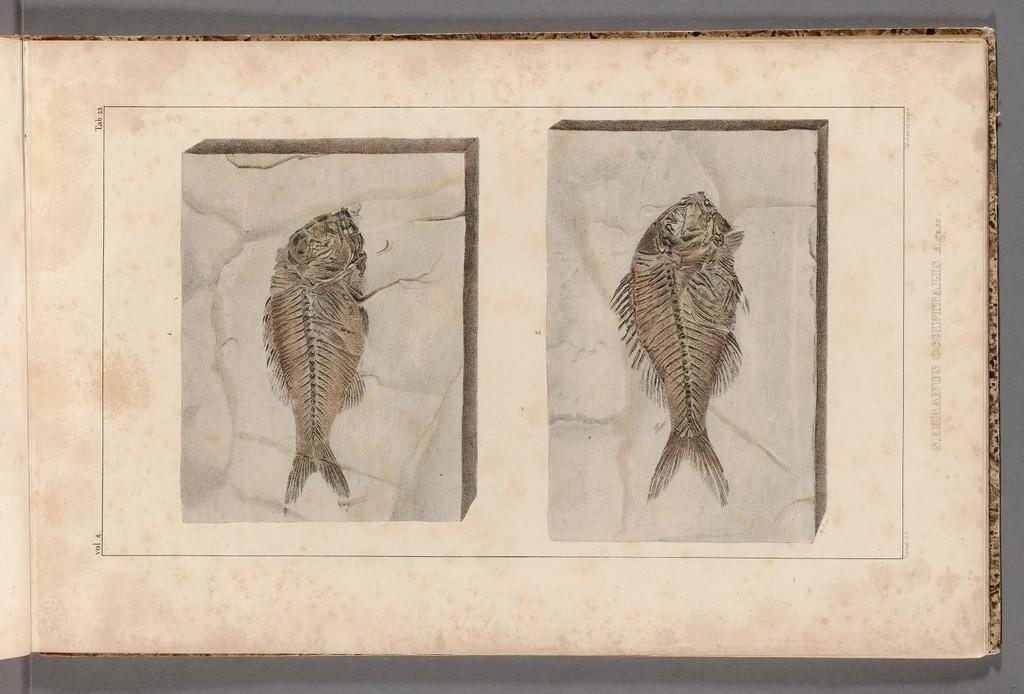What is the main subject in the center of the image? There is a sheet in the center of the image. What can be seen on the sheet? The sheet has pictures of fishes on it. What type of hate can be seen on the sheet in the image? There is no hate present on the sheet in the image; it features pictures of fishes. How many bees are depicted on the sheet in the image? There are no bees depicted on the sheet in the image; it features pictures of fishes. 